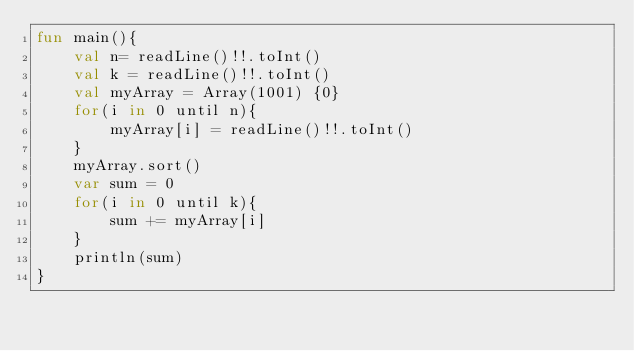Convert code to text. <code><loc_0><loc_0><loc_500><loc_500><_Kotlin_>fun main(){
    val n= readLine()!!.toInt()
    val k = readLine()!!.toInt()
    val myArray = Array(1001) {0}
    for(i in 0 until n){
        myArray[i] = readLine()!!.toInt()
    }
    myArray.sort()
    var sum = 0
    for(i in 0 until k){
        sum += myArray[i]
    }
    println(sum)
}</code> 